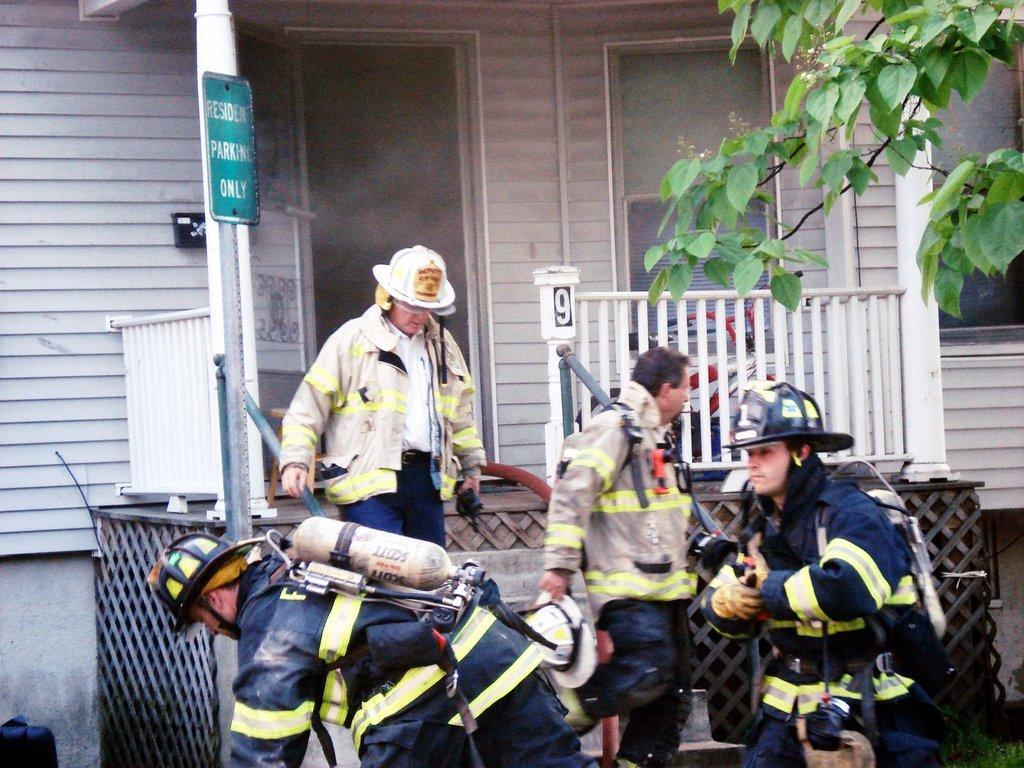In one or two sentences, can you explain what this image depicts? In the center of the image we can see a few people are standing and they are in different costumes. And we can see they are wearing jackets and a few other objects. Among them, we can see two persons are wearing helmets and two persons are holding some objects. In the background there is a wall, sign board, poles, fences, one tree, grass, windows and a few other objects. On the sign board, we can see some text. 